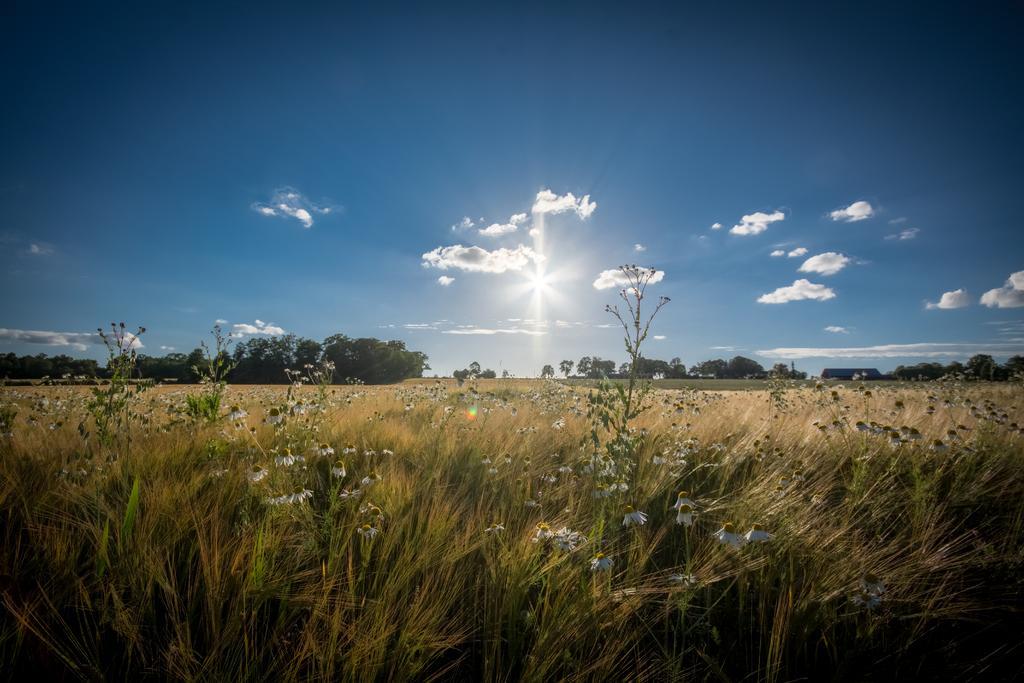Could you give a brief overview of what you see in this image? On the down side it is grass, on the left side there are green plants. In the middle it's a beautiful sunny sky. 